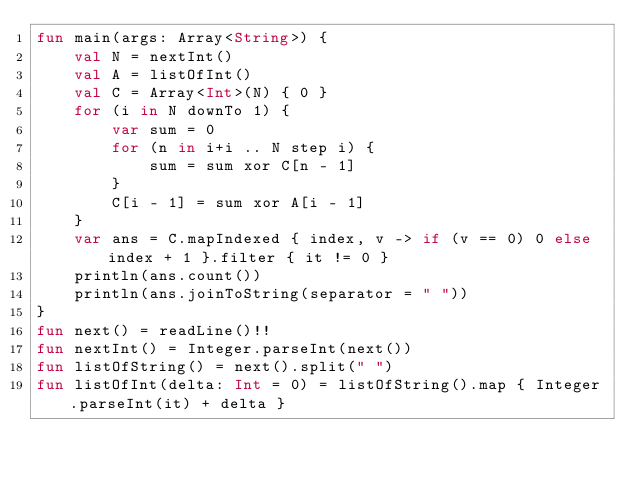Convert code to text. <code><loc_0><loc_0><loc_500><loc_500><_Kotlin_>fun main(args: Array<String>) {
    val N = nextInt()
    val A = listOfInt()
    val C = Array<Int>(N) { 0 }
    for (i in N downTo 1) {
        var sum = 0
        for (n in i+i .. N step i) {
            sum = sum xor C[n - 1]
        }
        C[i - 1] = sum xor A[i - 1]
    }
    var ans = C.mapIndexed { index, v -> if (v == 0) 0 else index + 1 }.filter { it != 0 }
    println(ans.count())
    println(ans.joinToString(separator = " "))
}
fun next() = readLine()!!
fun nextInt() = Integer.parseInt(next())
fun listOfString() = next().split(" ")
fun listOfInt(delta: Int = 0) = listOfString().map { Integer.parseInt(it) + delta }
</code> 